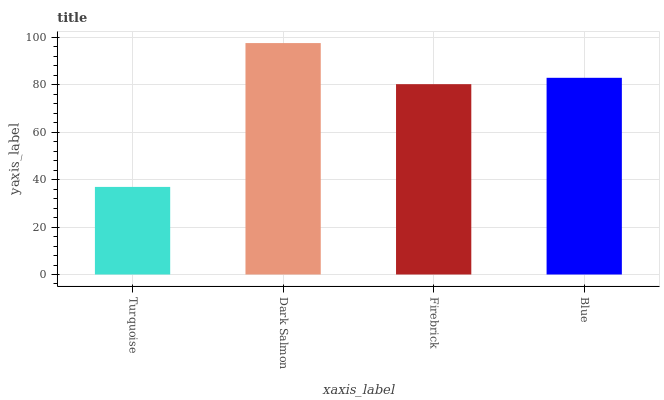Is Turquoise the minimum?
Answer yes or no. Yes. Is Dark Salmon the maximum?
Answer yes or no. Yes. Is Firebrick the minimum?
Answer yes or no. No. Is Firebrick the maximum?
Answer yes or no. No. Is Dark Salmon greater than Firebrick?
Answer yes or no. Yes. Is Firebrick less than Dark Salmon?
Answer yes or no. Yes. Is Firebrick greater than Dark Salmon?
Answer yes or no. No. Is Dark Salmon less than Firebrick?
Answer yes or no. No. Is Blue the high median?
Answer yes or no. Yes. Is Firebrick the low median?
Answer yes or no. Yes. Is Firebrick the high median?
Answer yes or no. No. Is Dark Salmon the low median?
Answer yes or no. No. 